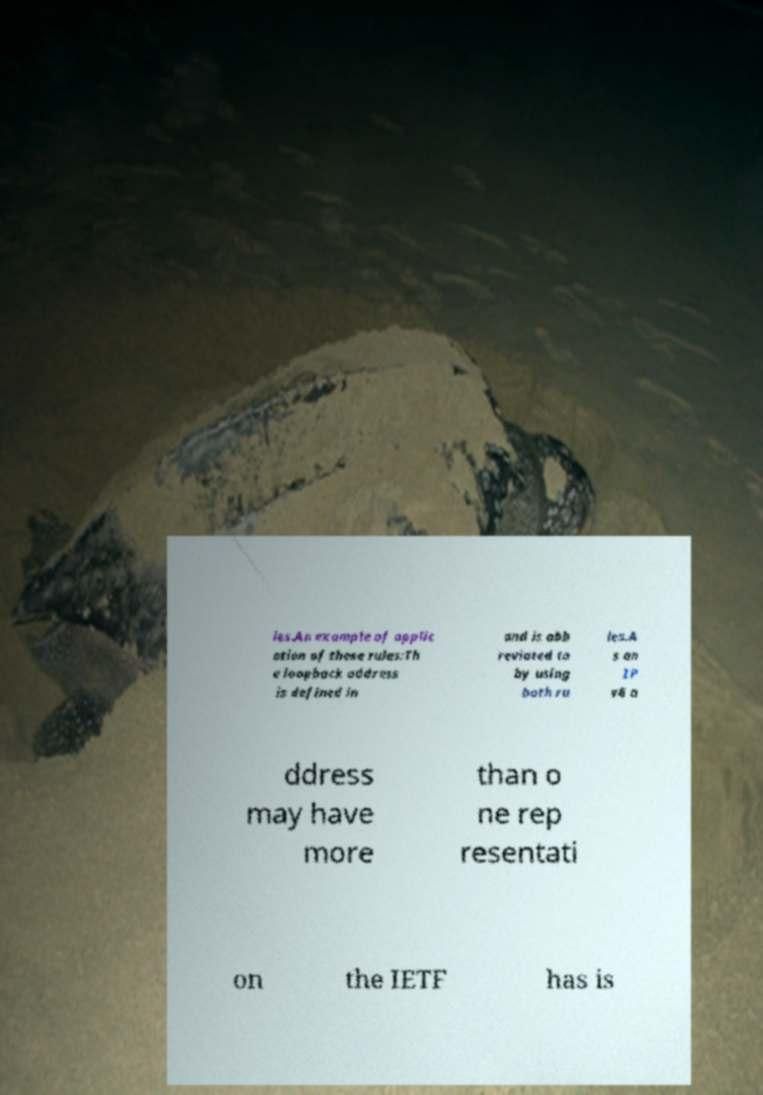Please identify and transcribe the text found in this image. les.An example of applic ation of these rules:Th e loopback address is defined in and is abb reviated to by using both ru les.A s an IP v6 a ddress may have more than o ne rep resentati on the IETF has is 